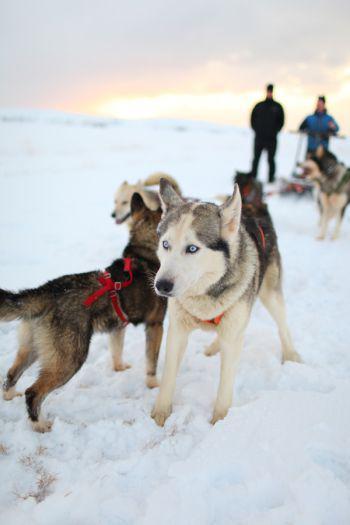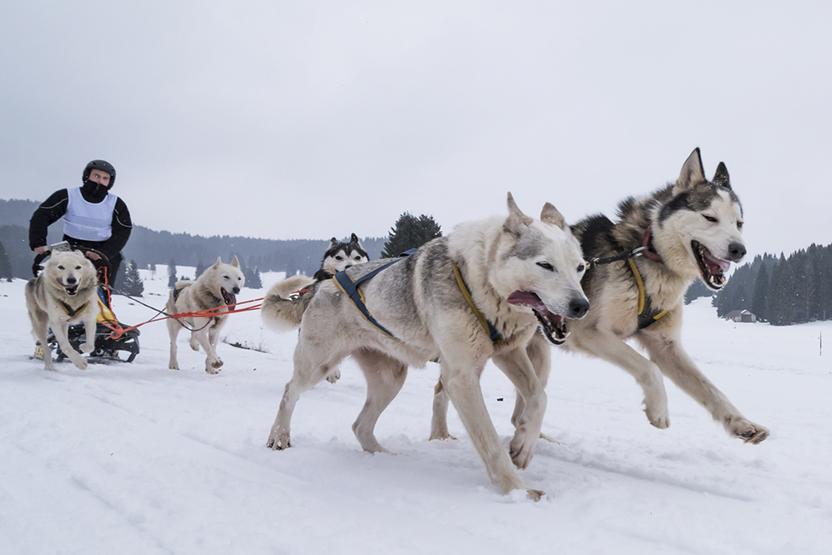The first image is the image on the left, the second image is the image on the right. Assess this claim about the two images: "The right image shows a dog team racing forward and toward the right, and the left image shows a dog team that is not moving.". Correct or not? Answer yes or no. Yes. The first image is the image on the left, the second image is the image on the right. Assess this claim about the two images: "There are four huskies pulling a sled across the snow.". Correct or not? Answer yes or no. No. 